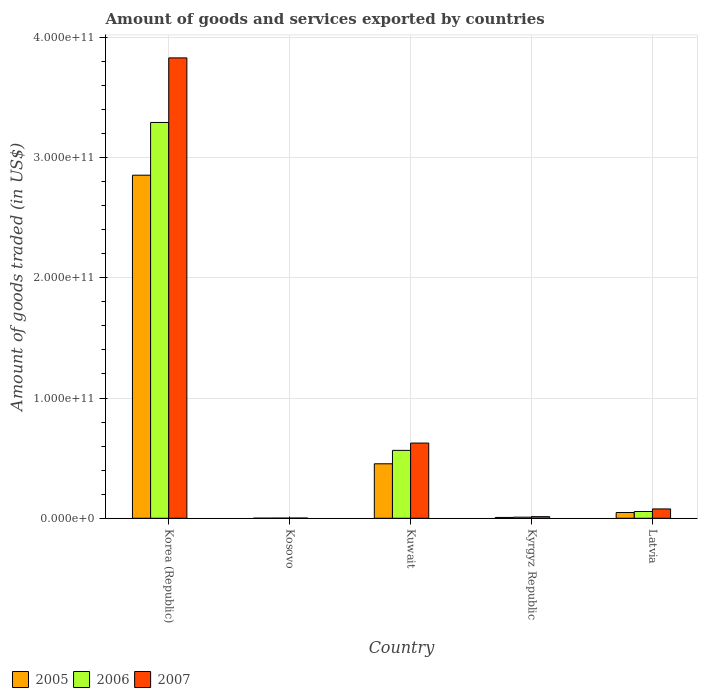How many different coloured bars are there?
Make the answer very short. 3. What is the label of the 4th group of bars from the left?
Offer a terse response. Kyrgyz Republic. In how many cases, is the number of bars for a given country not equal to the number of legend labels?
Your answer should be very brief. 0. What is the total amount of goods and services exported in 2006 in Kyrgyz Republic?
Your answer should be very brief. 9.06e+08. Across all countries, what is the maximum total amount of goods and services exported in 2007?
Your answer should be very brief. 3.83e+11. Across all countries, what is the minimum total amount of goods and services exported in 2005?
Your answer should be compact. 7.96e+07. In which country was the total amount of goods and services exported in 2006 maximum?
Offer a very short reply. Korea (Republic). In which country was the total amount of goods and services exported in 2007 minimum?
Your response must be concise. Kosovo. What is the total total amount of goods and services exported in 2007 in the graph?
Your answer should be compact. 4.55e+11. What is the difference between the total amount of goods and services exported in 2007 in Kuwait and that in Latvia?
Give a very brief answer. 5.48e+1. What is the difference between the total amount of goods and services exported in 2005 in Latvia and the total amount of goods and services exported in 2007 in Kuwait?
Your answer should be very brief. -5.77e+1. What is the average total amount of goods and services exported in 2005 per country?
Your response must be concise. 6.72e+1. What is the difference between the total amount of goods and services exported of/in 2006 and total amount of goods and services exported of/in 2007 in Kyrgyz Republic?
Make the answer very short. -4.32e+08. What is the ratio of the total amount of goods and services exported in 2007 in Kyrgyz Republic to that in Latvia?
Provide a short and direct response. 0.17. What is the difference between the highest and the second highest total amount of goods and services exported in 2006?
Provide a succinct answer. 2.73e+11. What is the difference between the highest and the lowest total amount of goods and services exported in 2007?
Give a very brief answer. 3.83e+11. In how many countries, is the total amount of goods and services exported in 2005 greater than the average total amount of goods and services exported in 2005 taken over all countries?
Offer a terse response. 1. What does the 1st bar from the left in Kuwait represents?
Offer a terse response. 2005. Is it the case that in every country, the sum of the total amount of goods and services exported in 2007 and total amount of goods and services exported in 2005 is greater than the total amount of goods and services exported in 2006?
Give a very brief answer. Yes. How many bars are there?
Keep it short and to the point. 15. Are all the bars in the graph horizontal?
Your answer should be compact. No. How many countries are there in the graph?
Offer a terse response. 5. What is the difference between two consecutive major ticks on the Y-axis?
Provide a short and direct response. 1.00e+11. Are the values on the major ticks of Y-axis written in scientific E-notation?
Give a very brief answer. Yes. Does the graph contain grids?
Your answer should be very brief. Yes. What is the title of the graph?
Keep it short and to the point. Amount of goods and services exported by countries. Does "1966" appear as one of the legend labels in the graph?
Your answer should be compact. No. What is the label or title of the X-axis?
Provide a succinct answer. Country. What is the label or title of the Y-axis?
Offer a very short reply. Amount of goods traded (in US$). What is the Amount of goods traded (in US$) in 2005 in Korea (Republic)?
Keep it short and to the point. 2.85e+11. What is the Amount of goods traded (in US$) in 2006 in Korea (Republic)?
Your response must be concise. 3.29e+11. What is the Amount of goods traded (in US$) in 2007 in Korea (Republic)?
Give a very brief answer. 3.83e+11. What is the Amount of goods traded (in US$) in 2005 in Kosovo?
Give a very brief answer. 7.96e+07. What is the Amount of goods traded (in US$) of 2006 in Kosovo?
Provide a short and direct response. 1.24e+08. What is the Amount of goods traded (in US$) in 2007 in Kosovo?
Make the answer very short. 1.82e+08. What is the Amount of goods traded (in US$) of 2005 in Kuwait?
Offer a terse response. 4.53e+1. What is the Amount of goods traded (in US$) in 2006 in Kuwait?
Your answer should be very brief. 5.65e+1. What is the Amount of goods traded (in US$) of 2007 in Kuwait?
Your answer should be compact. 6.25e+1. What is the Amount of goods traded (in US$) of 2005 in Kyrgyz Republic?
Offer a terse response. 6.87e+08. What is the Amount of goods traded (in US$) of 2006 in Kyrgyz Republic?
Your response must be concise. 9.06e+08. What is the Amount of goods traded (in US$) in 2007 in Kyrgyz Republic?
Offer a terse response. 1.34e+09. What is the Amount of goods traded (in US$) of 2005 in Latvia?
Ensure brevity in your answer.  4.80e+09. What is the Amount of goods traded (in US$) in 2006 in Latvia?
Offer a very short reply. 5.62e+09. What is the Amount of goods traded (in US$) of 2007 in Latvia?
Your response must be concise. 7.76e+09. Across all countries, what is the maximum Amount of goods traded (in US$) in 2005?
Provide a succinct answer. 2.85e+11. Across all countries, what is the maximum Amount of goods traded (in US$) in 2006?
Ensure brevity in your answer.  3.29e+11. Across all countries, what is the maximum Amount of goods traded (in US$) in 2007?
Offer a very short reply. 3.83e+11. Across all countries, what is the minimum Amount of goods traded (in US$) in 2005?
Provide a succinct answer. 7.96e+07. Across all countries, what is the minimum Amount of goods traded (in US$) of 2006?
Provide a short and direct response. 1.24e+08. Across all countries, what is the minimum Amount of goods traded (in US$) of 2007?
Make the answer very short. 1.82e+08. What is the total Amount of goods traded (in US$) of 2005 in the graph?
Keep it short and to the point. 3.36e+11. What is the total Amount of goods traded (in US$) in 2006 in the graph?
Make the answer very short. 3.92e+11. What is the total Amount of goods traded (in US$) of 2007 in the graph?
Provide a short and direct response. 4.55e+11. What is the difference between the Amount of goods traded (in US$) in 2005 in Korea (Republic) and that in Kosovo?
Keep it short and to the point. 2.85e+11. What is the difference between the Amount of goods traded (in US$) of 2006 in Korea (Republic) and that in Kosovo?
Your response must be concise. 3.29e+11. What is the difference between the Amount of goods traded (in US$) of 2007 in Korea (Republic) and that in Kosovo?
Keep it short and to the point. 3.83e+11. What is the difference between the Amount of goods traded (in US$) of 2005 in Korea (Republic) and that in Kuwait?
Your answer should be compact. 2.40e+11. What is the difference between the Amount of goods traded (in US$) of 2006 in Korea (Republic) and that in Kuwait?
Offer a terse response. 2.73e+11. What is the difference between the Amount of goods traded (in US$) in 2007 in Korea (Republic) and that in Kuwait?
Keep it short and to the point. 3.20e+11. What is the difference between the Amount of goods traded (in US$) in 2005 in Korea (Republic) and that in Kyrgyz Republic?
Provide a short and direct response. 2.85e+11. What is the difference between the Amount of goods traded (in US$) of 2006 in Korea (Republic) and that in Kyrgyz Republic?
Provide a short and direct response. 3.28e+11. What is the difference between the Amount of goods traded (in US$) in 2007 in Korea (Republic) and that in Kyrgyz Republic?
Offer a very short reply. 3.81e+11. What is the difference between the Amount of goods traded (in US$) of 2005 in Korea (Republic) and that in Latvia?
Make the answer very short. 2.80e+11. What is the difference between the Amount of goods traded (in US$) in 2006 in Korea (Republic) and that in Latvia?
Keep it short and to the point. 3.23e+11. What is the difference between the Amount of goods traded (in US$) of 2007 in Korea (Republic) and that in Latvia?
Your answer should be compact. 3.75e+11. What is the difference between the Amount of goods traded (in US$) in 2005 in Kosovo and that in Kuwait?
Provide a succinct answer. -4.52e+1. What is the difference between the Amount of goods traded (in US$) of 2006 in Kosovo and that in Kuwait?
Make the answer very short. -5.63e+1. What is the difference between the Amount of goods traded (in US$) of 2007 in Kosovo and that in Kuwait?
Keep it short and to the point. -6.23e+1. What is the difference between the Amount of goods traded (in US$) in 2005 in Kosovo and that in Kyrgyz Republic?
Keep it short and to the point. -6.07e+08. What is the difference between the Amount of goods traded (in US$) in 2006 in Kosovo and that in Kyrgyz Republic?
Your answer should be very brief. -7.82e+08. What is the difference between the Amount of goods traded (in US$) in 2007 in Kosovo and that in Kyrgyz Republic?
Your answer should be compact. -1.16e+09. What is the difference between the Amount of goods traded (in US$) of 2005 in Kosovo and that in Latvia?
Provide a short and direct response. -4.73e+09. What is the difference between the Amount of goods traded (in US$) of 2006 in Kosovo and that in Latvia?
Provide a short and direct response. -5.50e+09. What is the difference between the Amount of goods traded (in US$) in 2007 in Kosovo and that in Latvia?
Keep it short and to the point. -7.58e+09. What is the difference between the Amount of goods traded (in US$) of 2005 in Kuwait and that in Kyrgyz Republic?
Keep it short and to the point. 4.46e+1. What is the difference between the Amount of goods traded (in US$) of 2006 in Kuwait and that in Kyrgyz Republic?
Offer a terse response. 5.55e+1. What is the difference between the Amount of goods traded (in US$) of 2007 in Kuwait and that in Kyrgyz Republic?
Offer a terse response. 6.12e+1. What is the difference between the Amount of goods traded (in US$) of 2005 in Kuwait and that in Latvia?
Provide a succinct answer. 4.05e+1. What is the difference between the Amount of goods traded (in US$) of 2006 in Kuwait and that in Latvia?
Provide a succinct answer. 5.08e+1. What is the difference between the Amount of goods traded (in US$) of 2007 in Kuwait and that in Latvia?
Your answer should be compact. 5.48e+1. What is the difference between the Amount of goods traded (in US$) of 2005 in Kyrgyz Republic and that in Latvia?
Offer a terse response. -4.12e+09. What is the difference between the Amount of goods traded (in US$) of 2006 in Kyrgyz Republic and that in Latvia?
Give a very brief answer. -4.71e+09. What is the difference between the Amount of goods traded (in US$) of 2007 in Kyrgyz Republic and that in Latvia?
Provide a short and direct response. -6.42e+09. What is the difference between the Amount of goods traded (in US$) of 2005 in Korea (Republic) and the Amount of goods traded (in US$) of 2006 in Kosovo?
Ensure brevity in your answer.  2.85e+11. What is the difference between the Amount of goods traded (in US$) in 2005 in Korea (Republic) and the Amount of goods traded (in US$) in 2007 in Kosovo?
Give a very brief answer. 2.85e+11. What is the difference between the Amount of goods traded (in US$) of 2006 in Korea (Republic) and the Amount of goods traded (in US$) of 2007 in Kosovo?
Make the answer very short. 3.29e+11. What is the difference between the Amount of goods traded (in US$) of 2005 in Korea (Republic) and the Amount of goods traded (in US$) of 2006 in Kuwait?
Offer a very short reply. 2.29e+11. What is the difference between the Amount of goods traded (in US$) in 2005 in Korea (Republic) and the Amount of goods traded (in US$) in 2007 in Kuwait?
Give a very brief answer. 2.23e+11. What is the difference between the Amount of goods traded (in US$) of 2006 in Korea (Republic) and the Amount of goods traded (in US$) of 2007 in Kuwait?
Offer a very short reply. 2.67e+11. What is the difference between the Amount of goods traded (in US$) in 2005 in Korea (Republic) and the Amount of goods traded (in US$) in 2006 in Kyrgyz Republic?
Make the answer very short. 2.84e+11. What is the difference between the Amount of goods traded (in US$) of 2005 in Korea (Republic) and the Amount of goods traded (in US$) of 2007 in Kyrgyz Republic?
Ensure brevity in your answer.  2.84e+11. What is the difference between the Amount of goods traded (in US$) in 2006 in Korea (Republic) and the Amount of goods traded (in US$) in 2007 in Kyrgyz Republic?
Your answer should be very brief. 3.28e+11. What is the difference between the Amount of goods traded (in US$) in 2005 in Korea (Republic) and the Amount of goods traded (in US$) in 2006 in Latvia?
Your response must be concise. 2.80e+11. What is the difference between the Amount of goods traded (in US$) in 2005 in Korea (Republic) and the Amount of goods traded (in US$) in 2007 in Latvia?
Your answer should be compact. 2.77e+11. What is the difference between the Amount of goods traded (in US$) of 2006 in Korea (Republic) and the Amount of goods traded (in US$) of 2007 in Latvia?
Your answer should be compact. 3.21e+11. What is the difference between the Amount of goods traded (in US$) in 2005 in Kosovo and the Amount of goods traded (in US$) in 2006 in Kuwait?
Your answer should be compact. -5.64e+1. What is the difference between the Amount of goods traded (in US$) of 2005 in Kosovo and the Amount of goods traded (in US$) of 2007 in Kuwait?
Your answer should be very brief. -6.24e+1. What is the difference between the Amount of goods traded (in US$) in 2006 in Kosovo and the Amount of goods traded (in US$) in 2007 in Kuwait?
Offer a very short reply. -6.24e+1. What is the difference between the Amount of goods traded (in US$) in 2005 in Kosovo and the Amount of goods traded (in US$) in 2006 in Kyrgyz Republic?
Make the answer very short. -8.26e+08. What is the difference between the Amount of goods traded (in US$) of 2005 in Kosovo and the Amount of goods traded (in US$) of 2007 in Kyrgyz Republic?
Give a very brief answer. -1.26e+09. What is the difference between the Amount of goods traded (in US$) of 2006 in Kosovo and the Amount of goods traded (in US$) of 2007 in Kyrgyz Republic?
Your answer should be compact. -1.21e+09. What is the difference between the Amount of goods traded (in US$) of 2005 in Kosovo and the Amount of goods traded (in US$) of 2006 in Latvia?
Keep it short and to the point. -5.54e+09. What is the difference between the Amount of goods traded (in US$) in 2005 in Kosovo and the Amount of goods traded (in US$) in 2007 in Latvia?
Offer a terse response. -7.68e+09. What is the difference between the Amount of goods traded (in US$) of 2006 in Kosovo and the Amount of goods traded (in US$) of 2007 in Latvia?
Make the answer very short. -7.64e+09. What is the difference between the Amount of goods traded (in US$) in 2005 in Kuwait and the Amount of goods traded (in US$) in 2006 in Kyrgyz Republic?
Keep it short and to the point. 4.44e+1. What is the difference between the Amount of goods traded (in US$) of 2005 in Kuwait and the Amount of goods traded (in US$) of 2007 in Kyrgyz Republic?
Your response must be concise. 4.40e+1. What is the difference between the Amount of goods traded (in US$) of 2006 in Kuwait and the Amount of goods traded (in US$) of 2007 in Kyrgyz Republic?
Make the answer very short. 5.51e+1. What is the difference between the Amount of goods traded (in US$) in 2005 in Kuwait and the Amount of goods traded (in US$) in 2006 in Latvia?
Provide a short and direct response. 3.97e+1. What is the difference between the Amount of goods traded (in US$) in 2005 in Kuwait and the Amount of goods traded (in US$) in 2007 in Latvia?
Provide a succinct answer. 3.75e+1. What is the difference between the Amount of goods traded (in US$) in 2006 in Kuwait and the Amount of goods traded (in US$) in 2007 in Latvia?
Ensure brevity in your answer.  4.87e+1. What is the difference between the Amount of goods traded (in US$) of 2005 in Kyrgyz Republic and the Amount of goods traded (in US$) of 2006 in Latvia?
Offer a very short reply. -4.93e+09. What is the difference between the Amount of goods traded (in US$) of 2005 in Kyrgyz Republic and the Amount of goods traded (in US$) of 2007 in Latvia?
Your response must be concise. -7.08e+09. What is the difference between the Amount of goods traded (in US$) of 2006 in Kyrgyz Republic and the Amount of goods traded (in US$) of 2007 in Latvia?
Ensure brevity in your answer.  -6.86e+09. What is the average Amount of goods traded (in US$) of 2005 per country?
Make the answer very short. 6.72e+1. What is the average Amount of goods traded (in US$) of 2006 per country?
Keep it short and to the point. 7.84e+1. What is the average Amount of goods traded (in US$) of 2007 per country?
Ensure brevity in your answer.  9.09e+1. What is the difference between the Amount of goods traded (in US$) in 2005 and Amount of goods traded (in US$) in 2006 in Korea (Republic)?
Your answer should be compact. -4.38e+1. What is the difference between the Amount of goods traded (in US$) in 2005 and Amount of goods traded (in US$) in 2007 in Korea (Republic)?
Keep it short and to the point. -9.75e+1. What is the difference between the Amount of goods traded (in US$) in 2006 and Amount of goods traded (in US$) in 2007 in Korea (Republic)?
Keep it short and to the point. -5.37e+1. What is the difference between the Amount of goods traded (in US$) of 2005 and Amount of goods traded (in US$) of 2006 in Kosovo?
Ensure brevity in your answer.  -4.40e+07. What is the difference between the Amount of goods traded (in US$) of 2005 and Amount of goods traded (in US$) of 2007 in Kosovo?
Ensure brevity in your answer.  -1.02e+08. What is the difference between the Amount of goods traded (in US$) in 2006 and Amount of goods traded (in US$) in 2007 in Kosovo?
Provide a short and direct response. -5.80e+07. What is the difference between the Amount of goods traded (in US$) of 2005 and Amount of goods traded (in US$) of 2006 in Kuwait?
Keep it short and to the point. -1.12e+1. What is the difference between the Amount of goods traded (in US$) of 2005 and Amount of goods traded (in US$) of 2007 in Kuwait?
Provide a succinct answer. -1.72e+1. What is the difference between the Amount of goods traded (in US$) of 2006 and Amount of goods traded (in US$) of 2007 in Kuwait?
Your answer should be compact. -6.07e+09. What is the difference between the Amount of goods traded (in US$) of 2005 and Amount of goods traded (in US$) of 2006 in Kyrgyz Republic?
Provide a short and direct response. -2.19e+08. What is the difference between the Amount of goods traded (in US$) in 2005 and Amount of goods traded (in US$) in 2007 in Kyrgyz Republic?
Provide a short and direct response. -6.51e+08. What is the difference between the Amount of goods traded (in US$) of 2006 and Amount of goods traded (in US$) of 2007 in Kyrgyz Republic?
Your answer should be very brief. -4.32e+08. What is the difference between the Amount of goods traded (in US$) in 2005 and Amount of goods traded (in US$) in 2006 in Latvia?
Provide a succinct answer. -8.14e+08. What is the difference between the Amount of goods traded (in US$) in 2005 and Amount of goods traded (in US$) in 2007 in Latvia?
Your answer should be compact. -2.96e+09. What is the difference between the Amount of goods traded (in US$) of 2006 and Amount of goods traded (in US$) of 2007 in Latvia?
Offer a very short reply. -2.14e+09. What is the ratio of the Amount of goods traded (in US$) in 2005 in Korea (Republic) to that in Kosovo?
Give a very brief answer. 3582.49. What is the ratio of the Amount of goods traded (in US$) of 2006 in Korea (Republic) to that in Kosovo?
Keep it short and to the point. 2662.76. What is the ratio of the Amount of goods traded (in US$) of 2007 in Korea (Republic) to that in Kosovo?
Keep it short and to the point. 2108.44. What is the ratio of the Amount of goods traded (in US$) in 2005 in Korea (Republic) to that in Kuwait?
Your response must be concise. 6.3. What is the ratio of the Amount of goods traded (in US$) in 2006 in Korea (Republic) to that in Kuwait?
Make the answer very short. 5.83. What is the ratio of the Amount of goods traded (in US$) in 2007 in Korea (Republic) to that in Kuwait?
Your response must be concise. 6.12. What is the ratio of the Amount of goods traded (in US$) in 2005 in Korea (Republic) to that in Kyrgyz Republic?
Your answer should be compact. 415.32. What is the ratio of the Amount of goods traded (in US$) in 2006 in Korea (Republic) to that in Kyrgyz Republic?
Offer a very short reply. 363.25. What is the ratio of the Amount of goods traded (in US$) of 2007 in Korea (Republic) to that in Kyrgyz Republic?
Offer a terse response. 286.12. What is the ratio of the Amount of goods traded (in US$) of 2005 in Korea (Republic) to that in Latvia?
Provide a short and direct response. 59.37. What is the ratio of the Amount of goods traded (in US$) of 2006 in Korea (Republic) to that in Latvia?
Offer a very short reply. 58.57. What is the ratio of the Amount of goods traded (in US$) of 2007 in Korea (Republic) to that in Latvia?
Provide a succinct answer. 49.31. What is the ratio of the Amount of goods traded (in US$) in 2005 in Kosovo to that in Kuwait?
Provide a short and direct response. 0. What is the ratio of the Amount of goods traded (in US$) in 2006 in Kosovo to that in Kuwait?
Keep it short and to the point. 0. What is the ratio of the Amount of goods traded (in US$) in 2007 in Kosovo to that in Kuwait?
Your answer should be very brief. 0. What is the ratio of the Amount of goods traded (in US$) in 2005 in Kosovo to that in Kyrgyz Republic?
Offer a terse response. 0.12. What is the ratio of the Amount of goods traded (in US$) of 2006 in Kosovo to that in Kyrgyz Republic?
Make the answer very short. 0.14. What is the ratio of the Amount of goods traded (in US$) in 2007 in Kosovo to that in Kyrgyz Republic?
Give a very brief answer. 0.14. What is the ratio of the Amount of goods traded (in US$) of 2005 in Kosovo to that in Latvia?
Keep it short and to the point. 0.02. What is the ratio of the Amount of goods traded (in US$) of 2006 in Kosovo to that in Latvia?
Provide a succinct answer. 0.02. What is the ratio of the Amount of goods traded (in US$) in 2007 in Kosovo to that in Latvia?
Ensure brevity in your answer.  0.02. What is the ratio of the Amount of goods traded (in US$) in 2005 in Kuwait to that in Kyrgyz Republic?
Keep it short and to the point. 65.96. What is the ratio of the Amount of goods traded (in US$) in 2006 in Kuwait to that in Kyrgyz Republic?
Offer a very short reply. 62.31. What is the ratio of the Amount of goods traded (in US$) of 2007 in Kuwait to that in Kyrgyz Republic?
Offer a very short reply. 46.74. What is the ratio of the Amount of goods traded (in US$) of 2005 in Kuwait to that in Latvia?
Make the answer very short. 9.43. What is the ratio of the Amount of goods traded (in US$) of 2006 in Kuwait to that in Latvia?
Make the answer very short. 10.05. What is the ratio of the Amount of goods traded (in US$) in 2007 in Kuwait to that in Latvia?
Your response must be concise. 8.05. What is the ratio of the Amount of goods traded (in US$) of 2005 in Kyrgyz Republic to that in Latvia?
Your answer should be very brief. 0.14. What is the ratio of the Amount of goods traded (in US$) in 2006 in Kyrgyz Republic to that in Latvia?
Offer a very short reply. 0.16. What is the ratio of the Amount of goods traded (in US$) of 2007 in Kyrgyz Republic to that in Latvia?
Your answer should be compact. 0.17. What is the difference between the highest and the second highest Amount of goods traded (in US$) of 2005?
Make the answer very short. 2.40e+11. What is the difference between the highest and the second highest Amount of goods traded (in US$) of 2006?
Keep it short and to the point. 2.73e+11. What is the difference between the highest and the second highest Amount of goods traded (in US$) of 2007?
Give a very brief answer. 3.20e+11. What is the difference between the highest and the lowest Amount of goods traded (in US$) of 2005?
Offer a very short reply. 2.85e+11. What is the difference between the highest and the lowest Amount of goods traded (in US$) of 2006?
Give a very brief answer. 3.29e+11. What is the difference between the highest and the lowest Amount of goods traded (in US$) in 2007?
Give a very brief answer. 3.83e+11. 